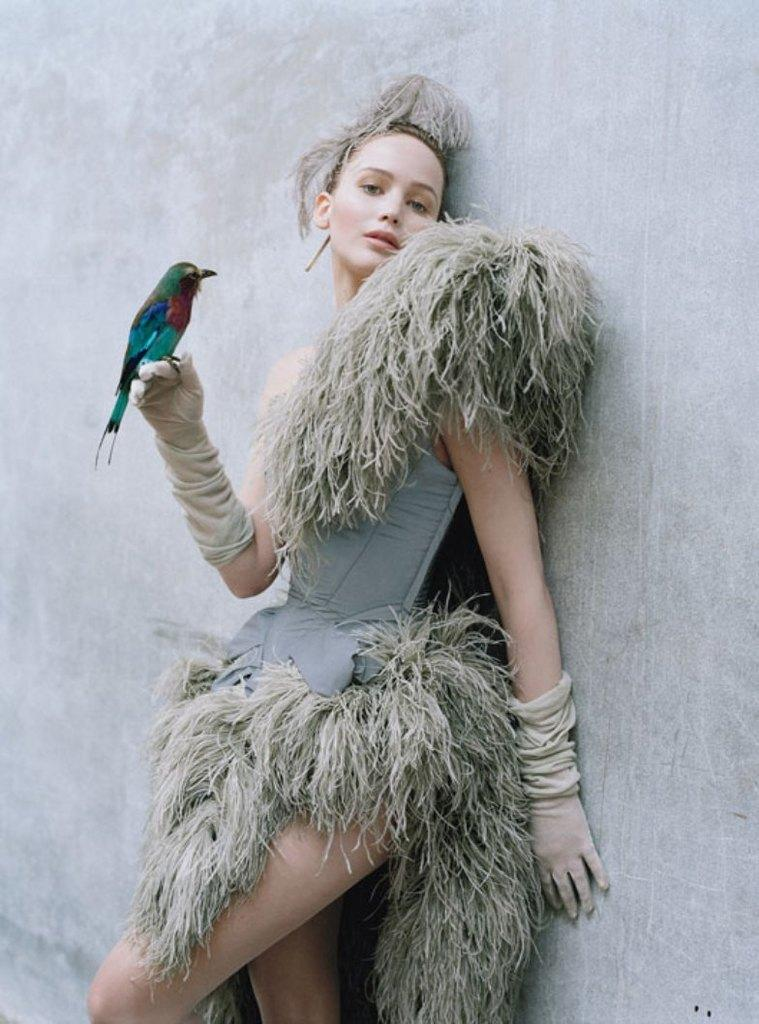What is the main subject of the image? There is a beautiful woman in the image. Where is the woman positioned in the image? The woman is standing near a wall. What is the woman wearing in the image? The woman is wearing a dress. Can you describe the woman's interaction with an animal in the image? There is a bird on the woman's right hand. What type of trouble is the woman facing in the image? There is no indication of trouble in the image; the woman appears to be interacting with a bird on her hand. Is the government mentioned or depicted in the image? No, the government is not mentioned or depicted in the image. 